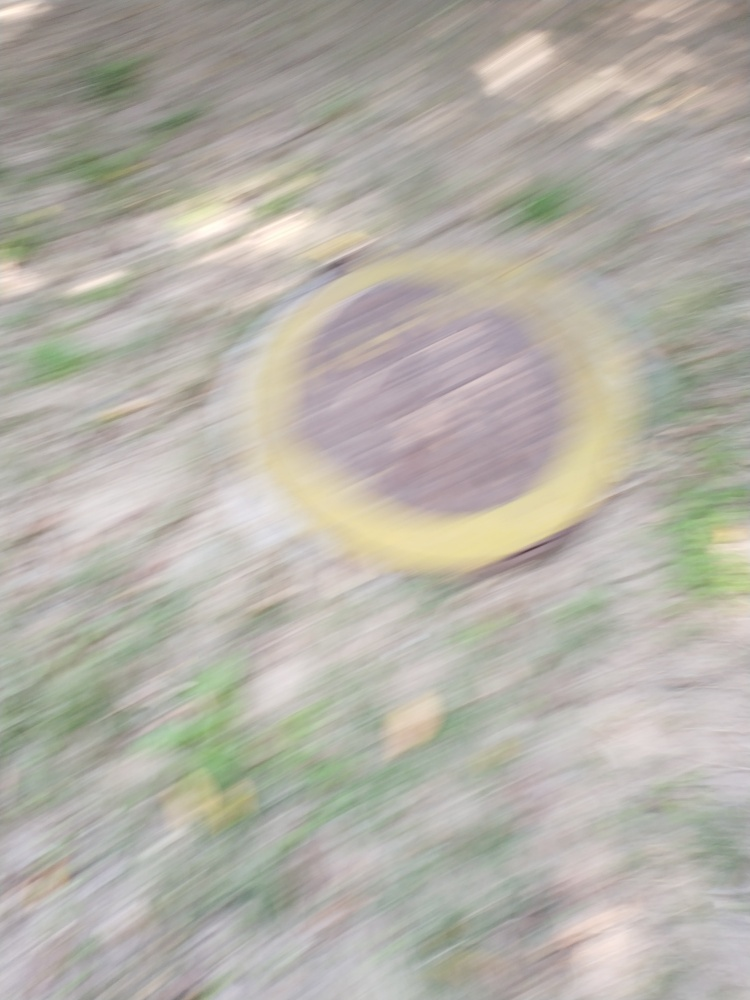Why is it difficult to see anything clearly in this image?
A. The image is well-focused.
B. The lighting conditions are poor.
C. The image is out of focus.
D. The lens used for capturing the image was low quality.
Answer with the option's letter from the given choices directly.
 C. 